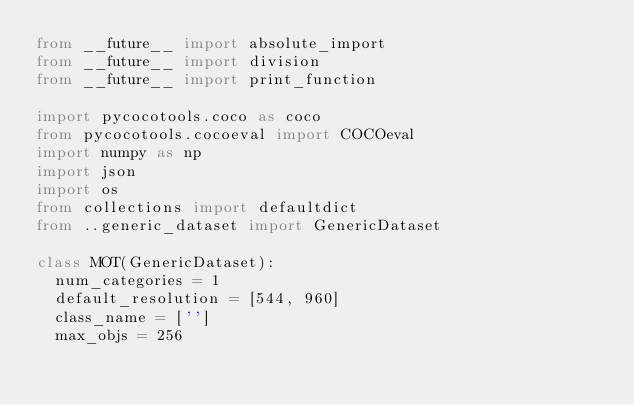Convert code to text. <code><loc_0><loc_0><loc_500><loc_500><_Python_>from __future__ import absolute_import
from __future__ import division
from __future__ import print_function

import pycocotools.coco as coco
from pycocotools.cocoeval import COCOeval
import numpy as np
import json
import os
from collections import defaultdict
from ..generic_dataset import GenericDataset

class MOT(GenericDataset):
  num_categories = 1
  default_resolution = [544, 960]
  class_name = ['']
  max_objs = 256</code> 